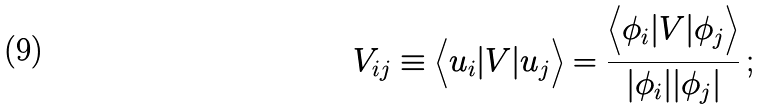<formula> <loc_0><loc_0><loc_500><loc_500>V _ { i j } \equiv \Big < u _ { i } | V | u _ { j } \Big > = \frac { \Big < \phi _ { i } | V | \phi _ { j } \Big > } { | \phi _ { i } | | \phi _ { j } | } \, ;</formula> 